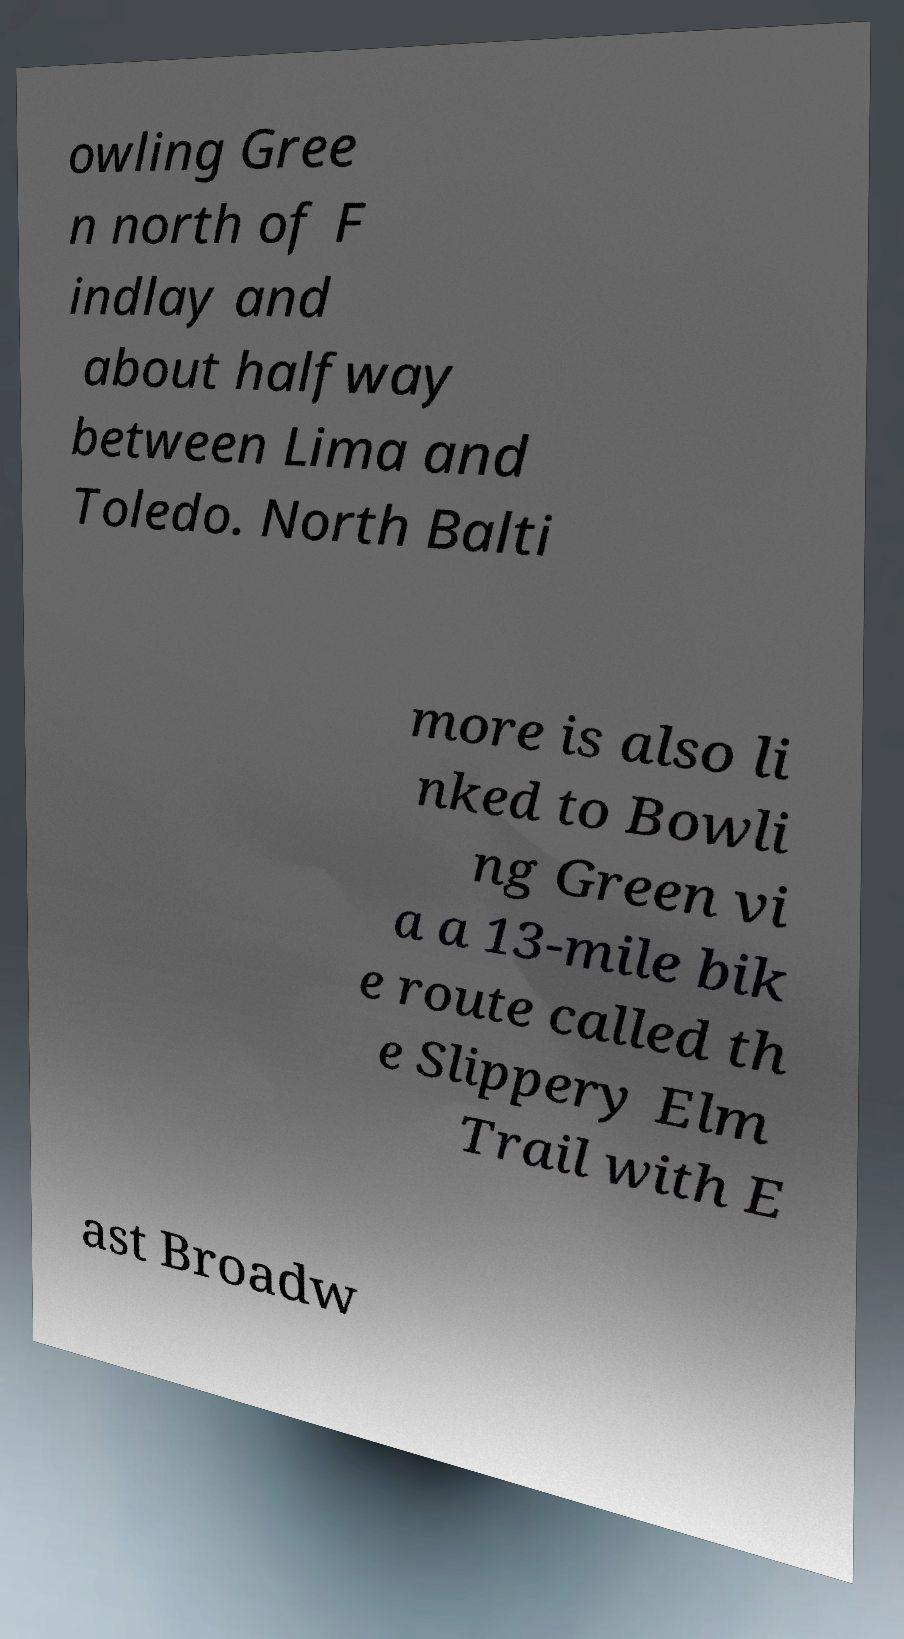There's text embedded in this image that I need extracted. Can you transcribe it verbatim? owling Gree n north of F indlay and about halfway between Lima and Toledo. North Balti more is also li nked to Bowli ng Green vi a a 13-mile bik e route called th e Slippery Elm Trail with E ast Broadw 